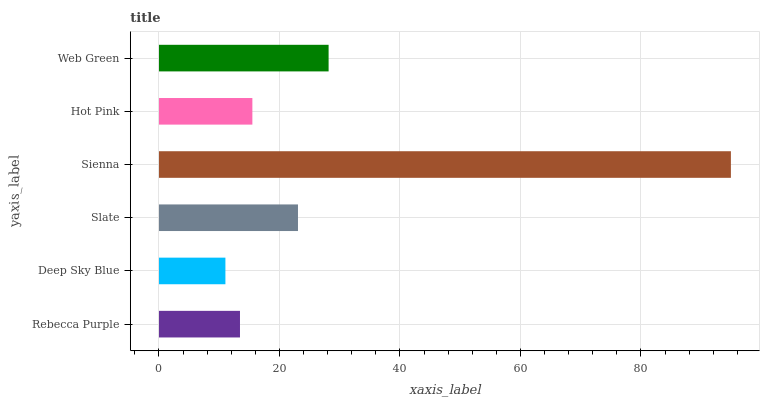Is Deep Sky Blue the minimum?
Answer yes or no. Yes. Is Sienna the maximum?
Answer yes or no. Yes. Is Slate the minimum?
Answer yes or no. No. Is Slate the maximum?
Answer yes or no. No. Is Slate greater than Deep Sky Blue?
Answer yes or no. Yes. Is Deep Sky Blue less than Slate?
Answer yes or no. Yes. Is Deep Sky Blue greater than Slate?
Answer yes or no. No. Is Slate less than Deep Sky Blue?
Answer yes or no. No. Is Slate the high median?
Answer yes or no. Yes. Is Hot Pink the low median?
Answer yes or no. Yes. Is Sienna the high median?
Answer yes or no. No. Is Rebecca Purple the low median?
Answer yes or no. No. 